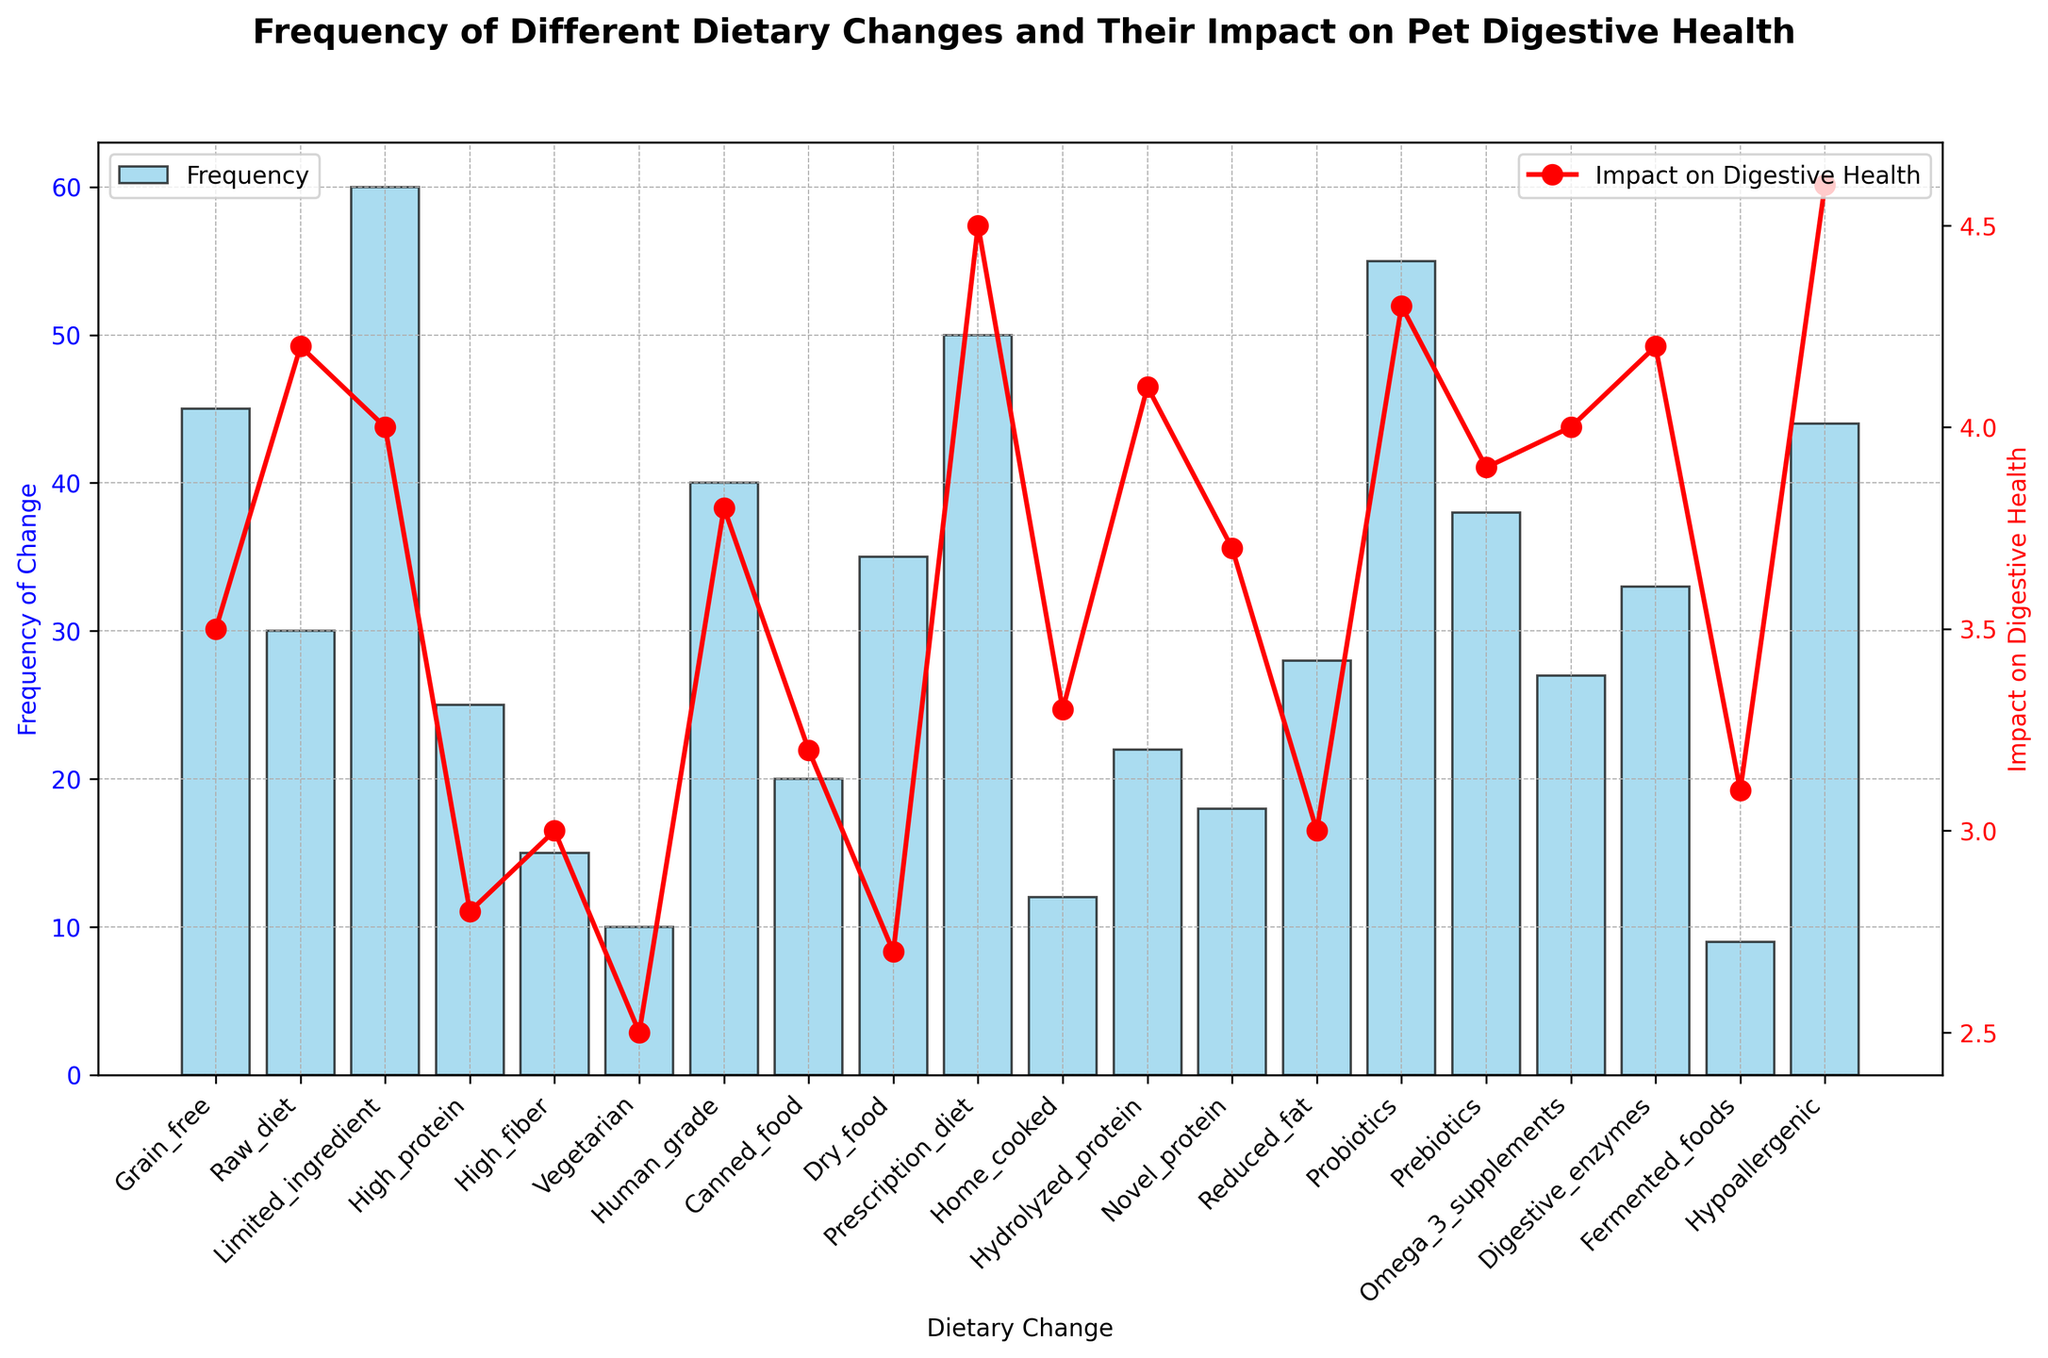Which dietary change has the highest frequency? Look at the bars of the histogram and find the bar with the greatest height. The tallest bar represents the dietary change with the highest frequency.
Answer: Limited ingredient What is the frequency difference between "Prescription diet" and "Vegetarian"? Identify the heights of the bars for "Prescription diet" and "Vegetarian". Subtract the height of the "Vegetarian" bar from the height of the "Prescription diet" bar (50 - 10).
Answer: 40 Which dietary change has the highest impact on digestive health? Look at the red line plot and find the point at the topmost location on the vertical axis labeled "Impact on Digestive Health".
Answer: Hypoallergenic How does the frequency of "Probiotics" compare to that of "Dry food"? Look at the height of the bars for both "Probiotics" and "Dry food". Compare the two heights.
Answer: Probiotics has a higher frequency than Dry food What is the average impact on digestive health for "Grain free", "Raw diet", and "Limited ingredient"? Find the impact values for "Grain free" (3.5), "Raw diet" (4.2), and "Limited ingredient" (4.0). Calculate the average by summing these values and dividing by 3 ( (3.5 + 4.2 + 4.0) / 3 ).
Answer: 3.9 Is there a dietary change with a low frequency but a high impact on digestive health? If so, which one? Find dietary changes with low frequencies by looking at the smaller bars and then check their corresponding impact values on the red line plot. Compare these values to find if any of them have a high impact.
Answer: Hydrolyzed protein Which dietary change has the least impact on digestive health? Look at the red line plot and identify the point at the lowest position on the vertical axis labeled "Impact on Digestive Health".
Answer: Vegetarian What is the total frequency of dietary changes with an impact on digestive health greater than 4.0? Identify the dietary changes with an impact on digestive health greater than 4.0. These are "Raw diet" (30), "Prescription diet" (50), "Probiotics" (55), "Hydrolyzed protein" (22), "Hypoallergenic" (44). Sum their frequencies (30 + 50 + 55 + 22 + 44).
Answer: 201 Is there any dietary change where the frequency and impact on digestive health are both average compared to the rest? To determine if a dietary change is average, compare both its frequency and impact to the overall dataset. Identify one that falls roughly in the center for both metrics. One good candidate is "Digestive enzymes" with frequency 33 and impact 4.2, which seem close to the middle of both distributions, but exact averages may vary.
Answer: Digestive enzymes How does the impact on digestive health of "High protein" compare to "Vegetarian"? Look at the red line plot and find the points for "High protein" and "Vegetarian". Compare these values.
Answer: High protein has a higher impact than Vegetarian 